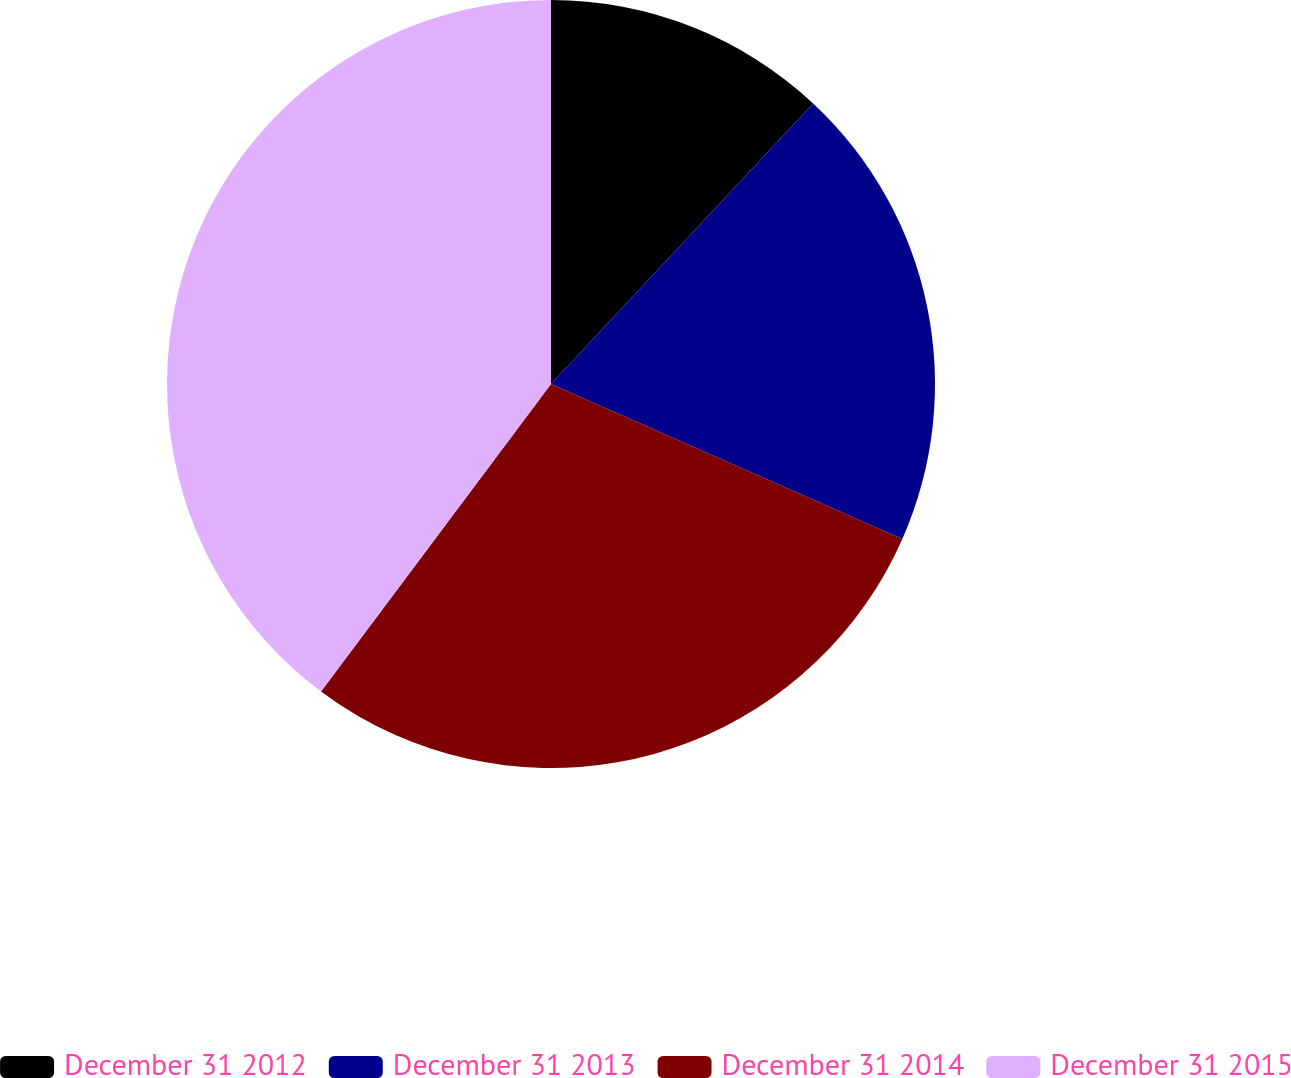Convert chart. <chart><loc_0><loc_0><loc_500><loc_500><pie_chart><fcel>December 31 2012<fcel>December 31 2013<fcel>December 31 2014<fcel>December 31 2015<nl><fcel>11.96%<fcel>19.65%<fcel>28.61%<fcel>39.78%<nl></chart> 